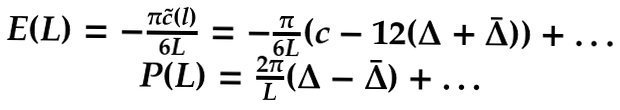Convert formula to latex. <formula><loc_0><loc_0><loc_500><loc_500>\begin{array} { c } E ( L ) = - \frac { \pi \tilde { c } ( l ) } { 6 L } = - \frac { \pi } { 6 L } ( c - 1 2 ( \Delta + \bar { \Delta } ) ) + \dots \\ P ( L ) = \frac { 2 \pi } { L } ( \Delta - \bar { \Delta } ) + \dots \end{array}</formula> 